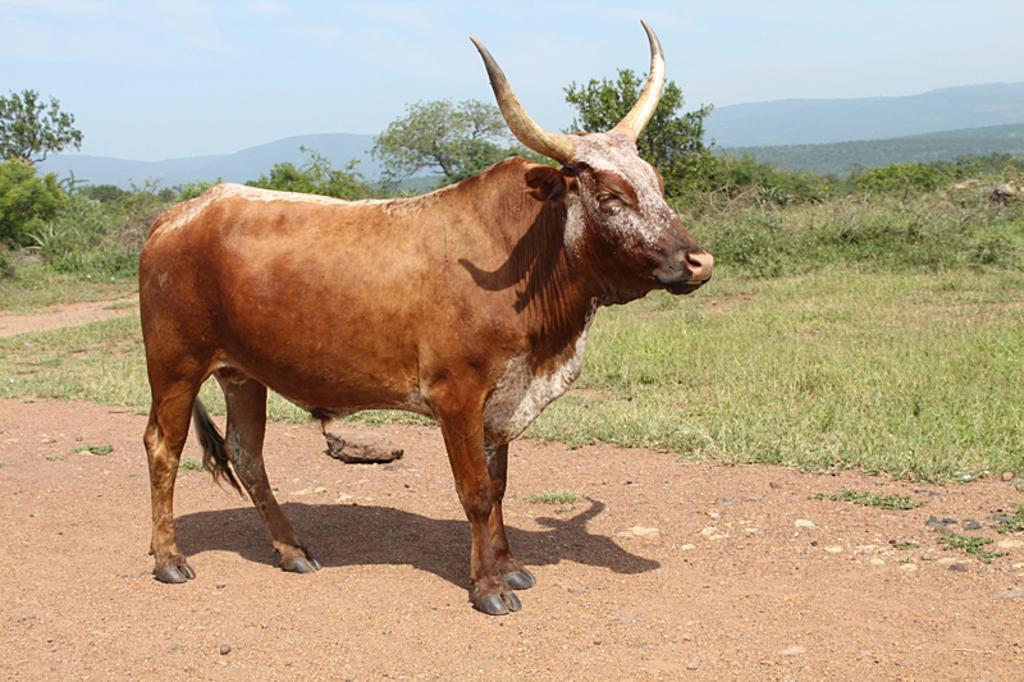Please provide a concise description of this image. In this image I can see a path in the front and on it I can see an ox is standing. I can see colour of the ox is brown and on the ground I can see a shadow. In the background I can see grass, number of trees, mountains and the sky. 